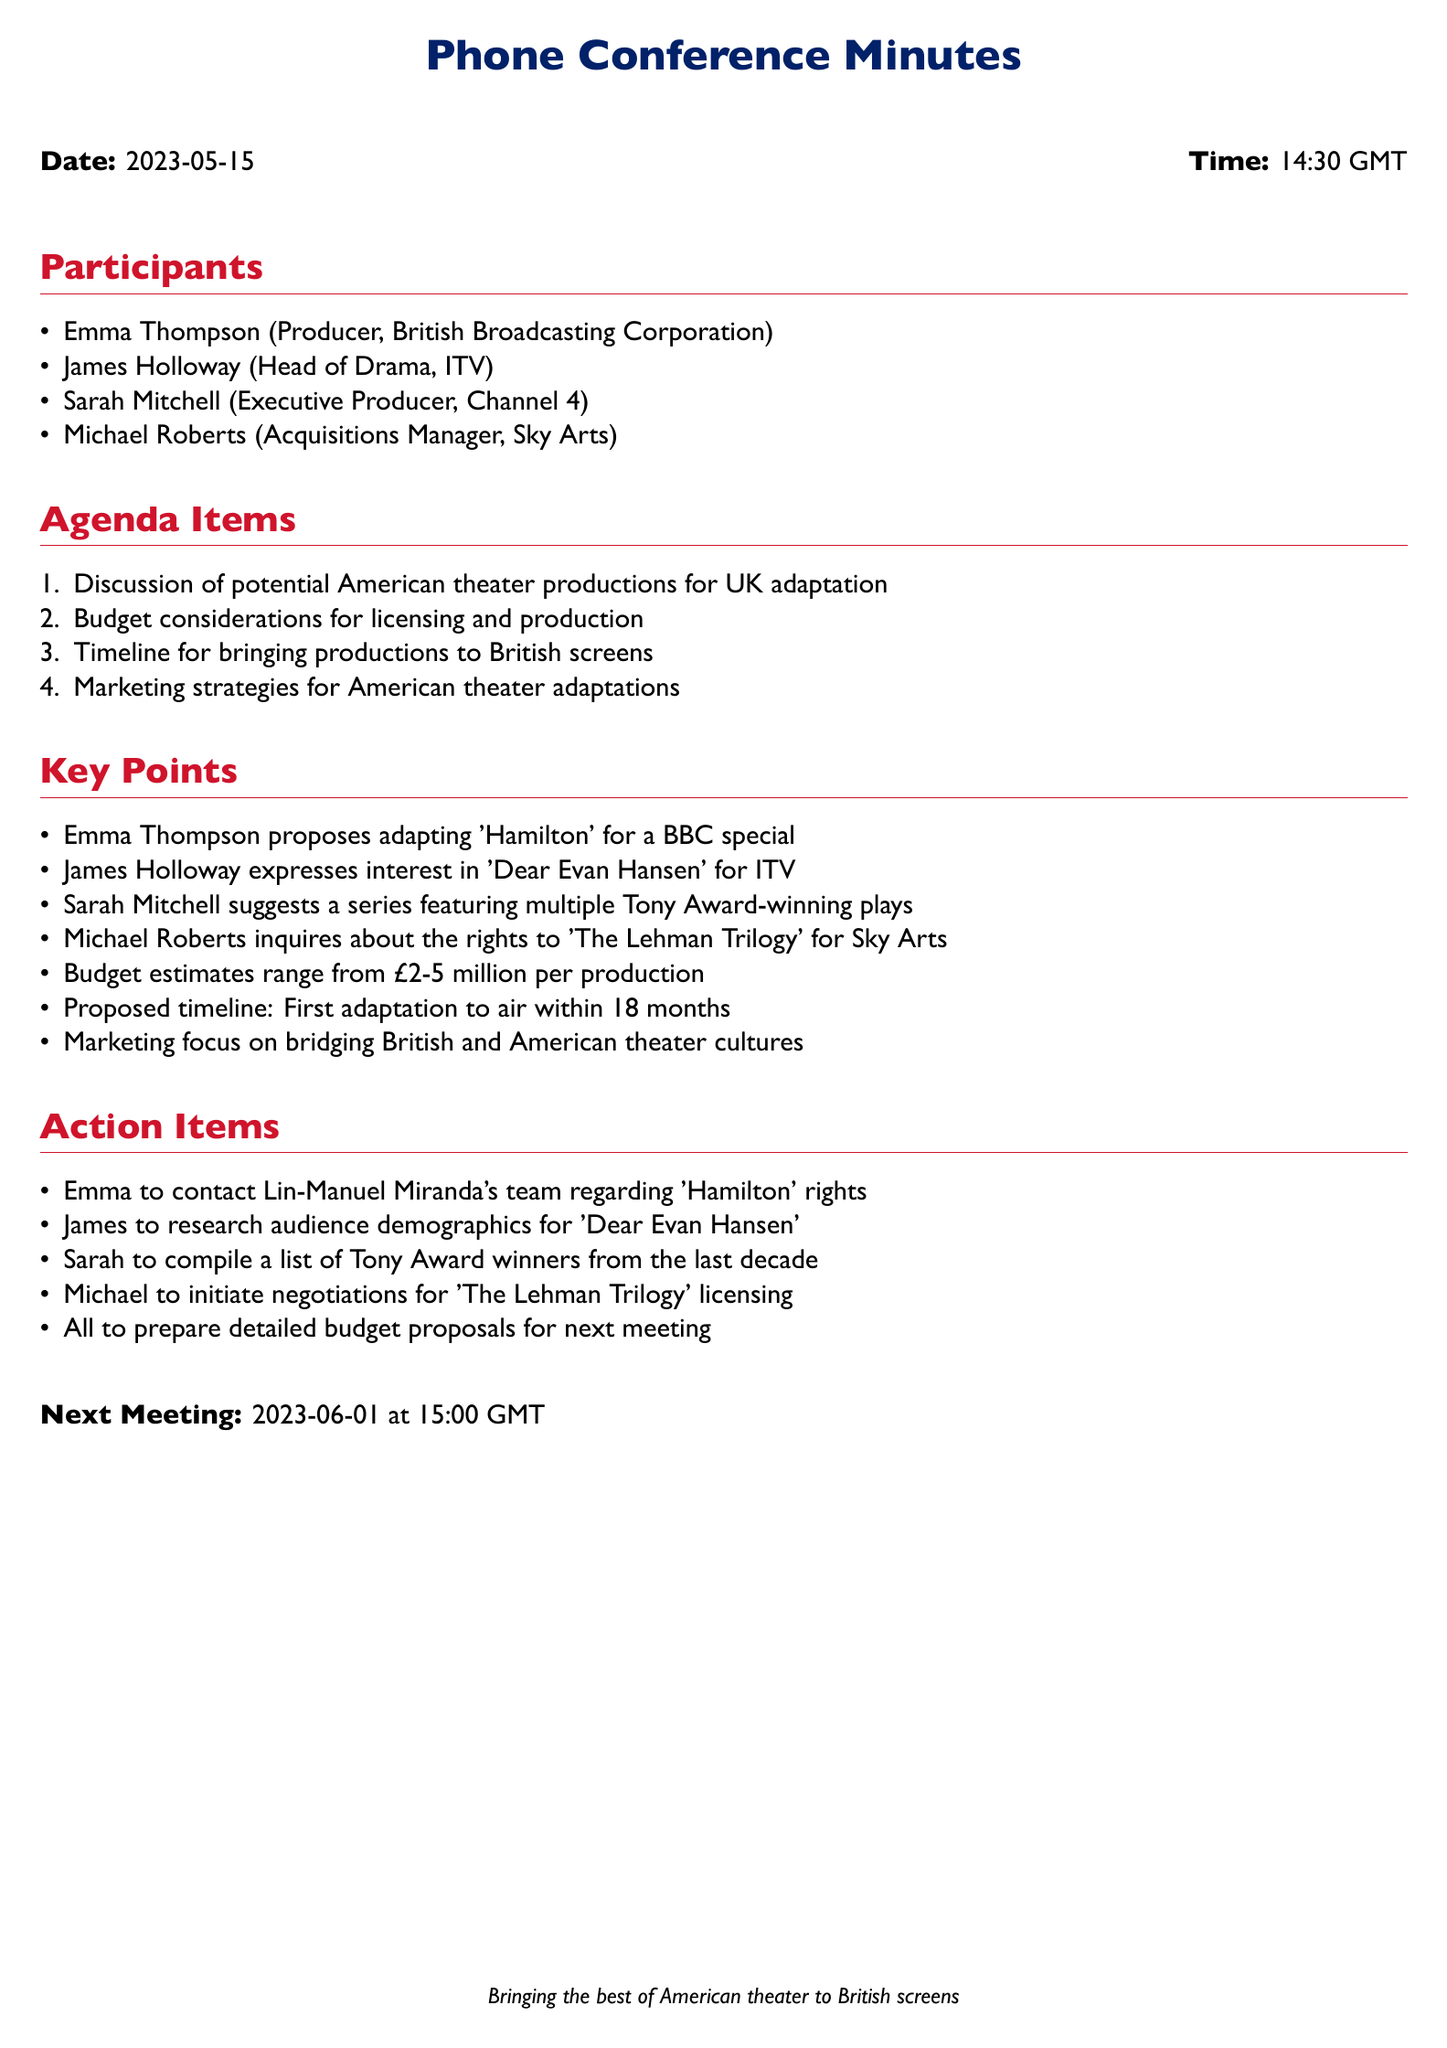What is the date of the conference? The date of the conference is stated prominently in the document as '2023-05-15'.
Answer: 2023-05-15 Who proposed adapting 'Hamilton'? The document specifies that 'Hamilton' was proposed for adaptation by Emma Thompson.
Answer: Emma Thompson What is the budget range mentioned for each production? The budget estimates provided in the document range from £2-5 million per production.
Answer: £2-5 million Which production does James Holloway express interest in? The document indicates James Holloway's interest in adapting 'Dear Evan Hansen' for ITV.
Answer: Dear Evan Hansen When is the next meeting scheduled? The next meeting date and time is mentioned as '2023-06-01 at 15:00 GMT'.
Answer: 2023-06-01 at 15:00 GMT What is the proposed timeline for the first adaptation to air? The timeline for the first adaptation is proposed to be within 18 months, as stated in the document.
Answer: 18 months What role does Sarah Mitchell hold? The document lists Sarah Mitchell as the Executive Producer for Channel 4.
Answer: Executive Producer Which production is Michael Roberts inquiring about rights for? According to the document, Michael Roberts is inquiring about the rights to 'The Lehman Trilogy'.
Answer: The Lehman Trilogy What is the main focus of the marketing strategies discussed? The marketing strategies are focused on bridging British and American theater cultures, as mentioned in the key points.
Answer: Bridging British and American theater cultures 